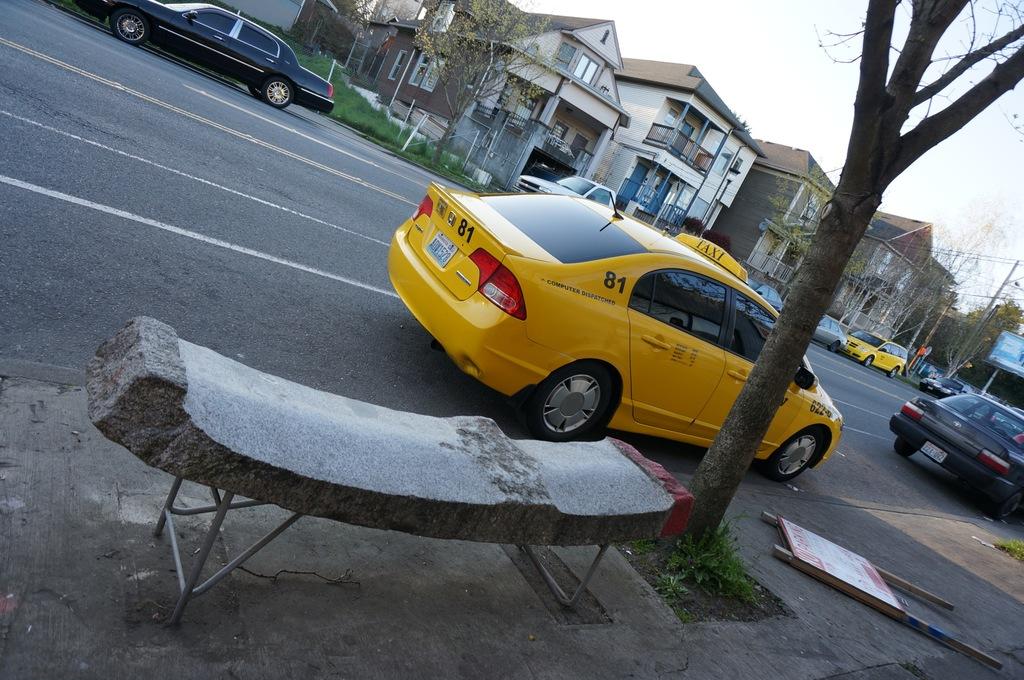What service does the car provide?
Offer a very short reply. Taxi. What is the cab number?
Provide a short and direct response. 81. 